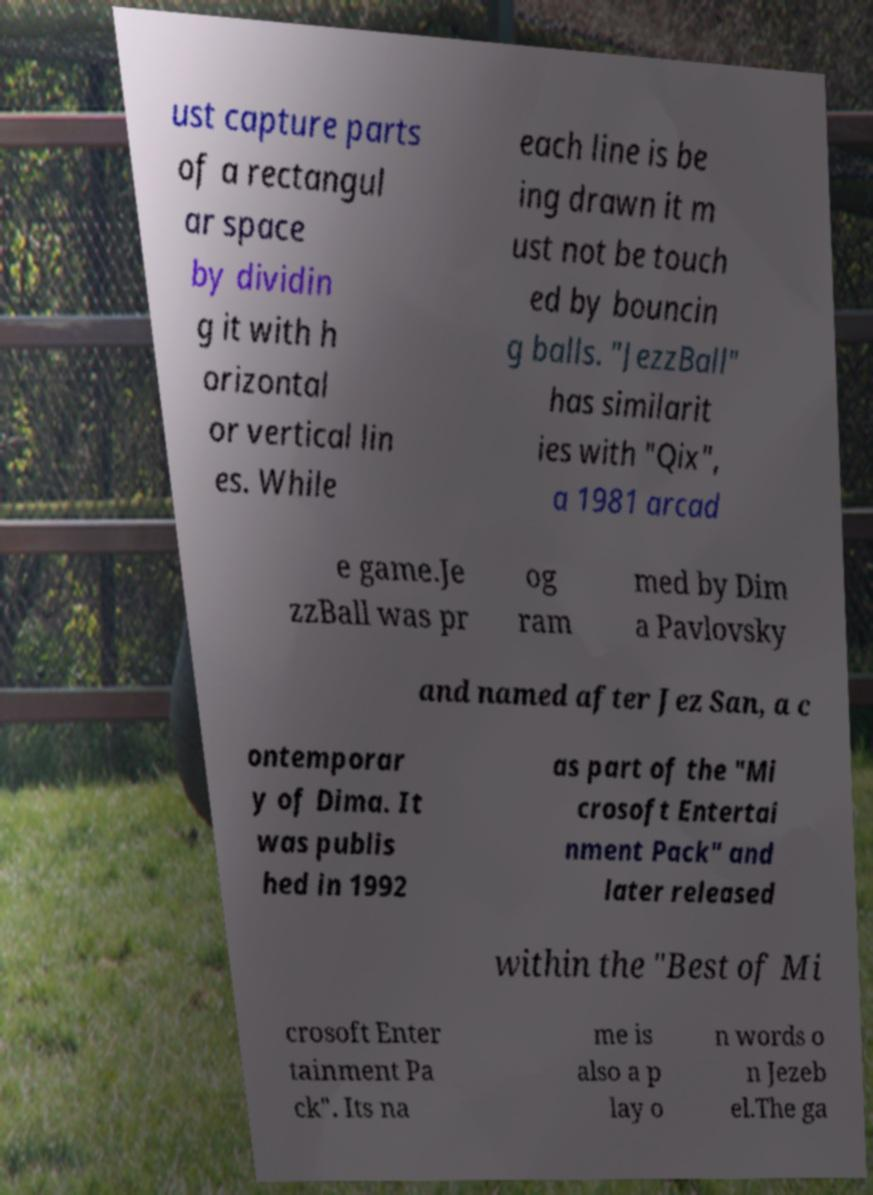What messages or text are displayed in this image? I need them in a readable, typed format. ust capture parts of a rectangul ar space by dividin g it with h orizontal or vertical lin es. While each line is be ing drawn it m ust not be touch ed by bouncin g balls. "JezzBall" has similarit ies with "Qix", a 1981 arcad e game.Je zzBall was pr og ram med by Dim a Pavlovsky and named after Jez San, a c ontemporar y of Dima. It was publis hed in 1992 as part of the "Mi crosoft Entertai nment Pack" and later released within the "Best of Mi crosoft Enter tainment Pa ck". Its na me is also a p lay o n words o n Jezeb el.The ga 